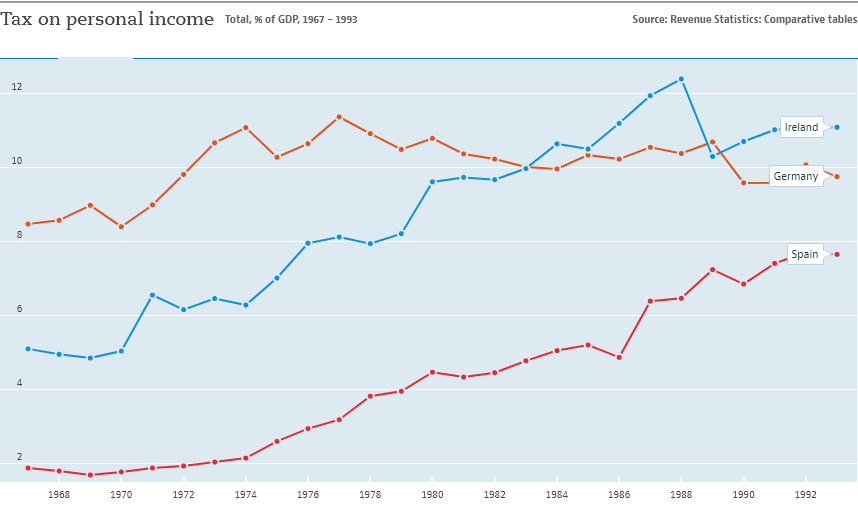Give some essential details in this illustration. The graph shows 13 years in total. In the year 1968, the sum of all the bars is equal to 15.4. 